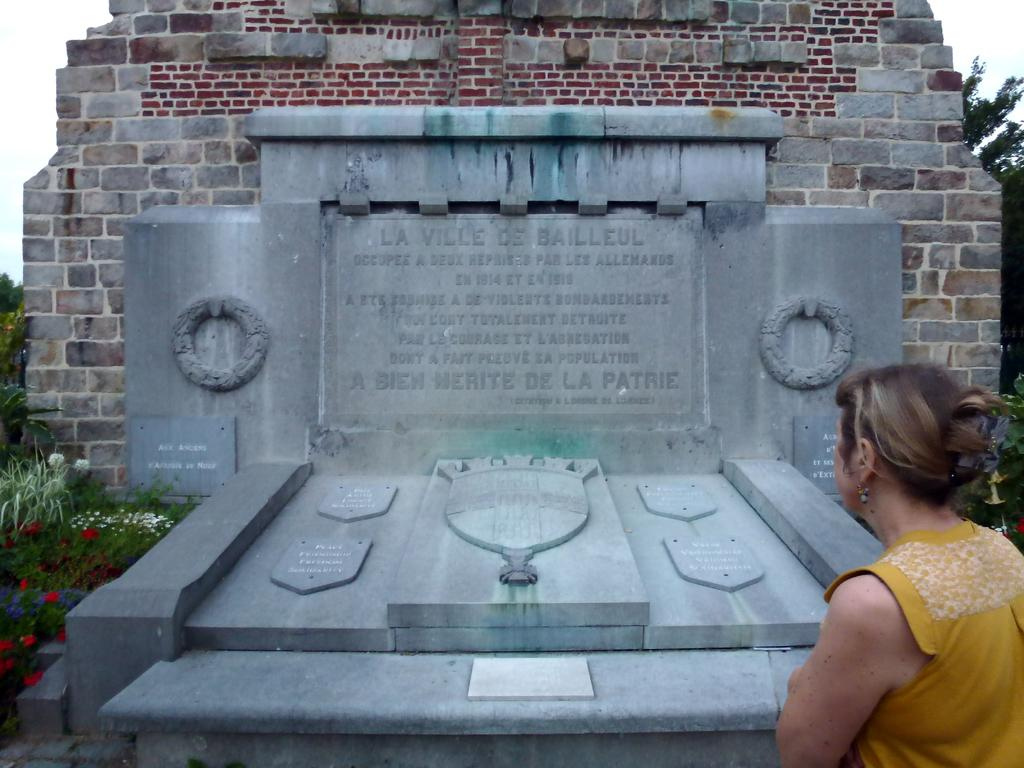What is the main object in the center of the image? There is a lay stone in the center of the image. What is written on the lay stone? There is text written on the lay stone. What can be seen in the background of the image? There are trees, plants, and flowers in the background of the image. Is there a person present in the image? Yes, there is a person in the image. What type of dust can be seen on the lay stone in the image? There is no dust visible on the lay stone in the image. 